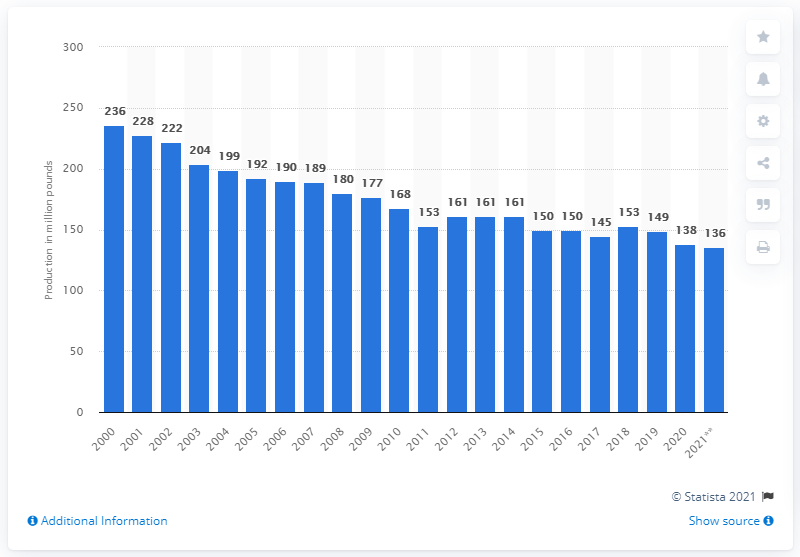Identify some key points in this picture. In 2001, a total of 228 pounds of lamb and mutton were produced. 